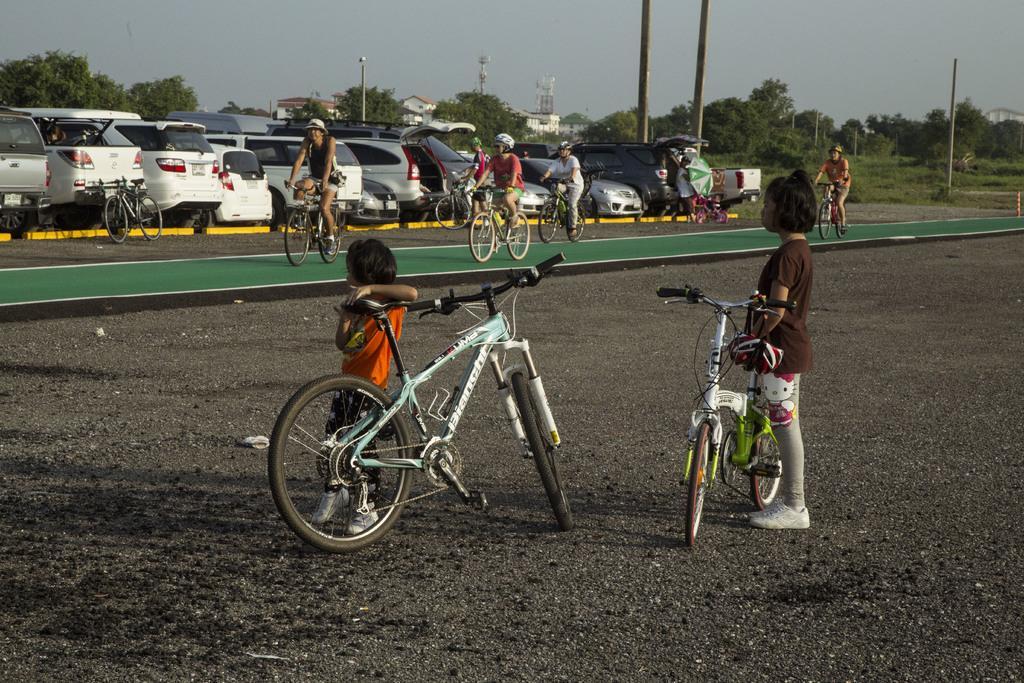How would you summarize this image in a sentence or two? In front of the picture, we see two girls are standing beside the bicycles. At the bottom, we see the road. Behind them, we see four men are riding the four bicycles. Beside them, we see two bicycles are parked. Beside that, we see many cars are parked. The man in white T-shirt is holding a green color umbrella in his hands. There are poles, trees, street lights, tower and buildings in the background. At the top, we see the sky. 